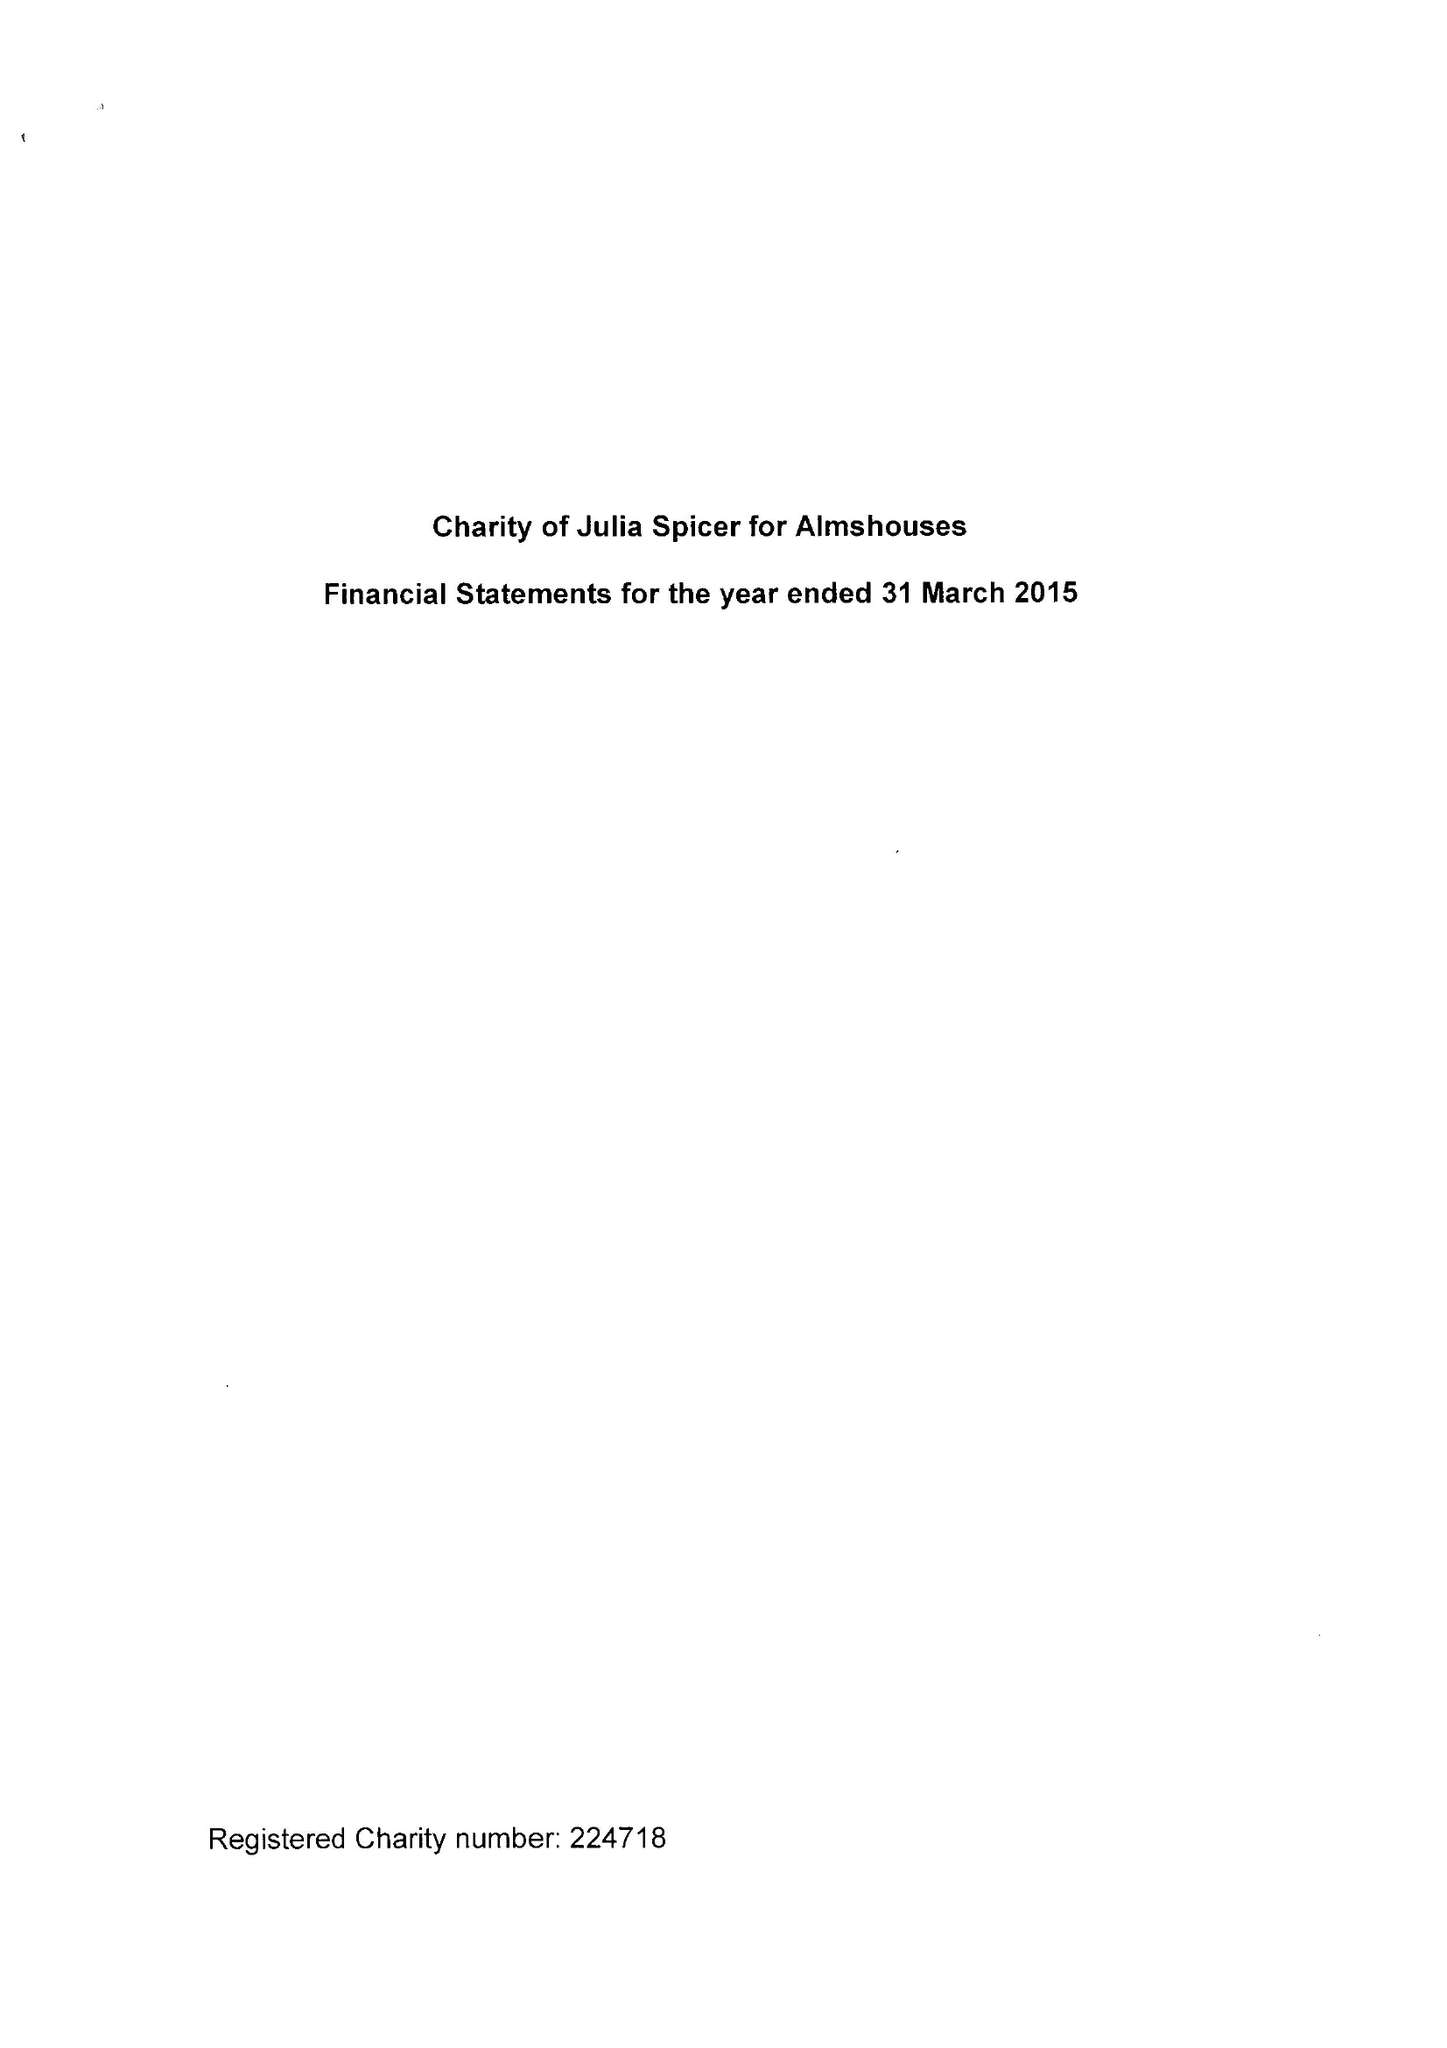What is the value for the address__post_town?
Answer the question using a single word or phrase. CROYDON 